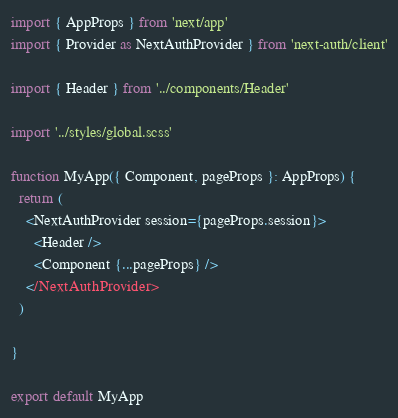Convert code to text. <code><loc_0><loc_0><loc_500><loc_500><_TypeScript_>import { AppProps } from 'next/app'
import { Provider as NextAuthProvider } from 'next-auth/client'

import { Header } from '../components/Header'

import '../styles/global.scss'

function MyApp({ Component, pageProps }: AppProps) {
  return (
    <NextAuthProvider session={pageProps.session}>
      <Header />
      <Component {...pageProps} />
    </NextAuthProvider>
  )

}

export default MyApp
</code> 